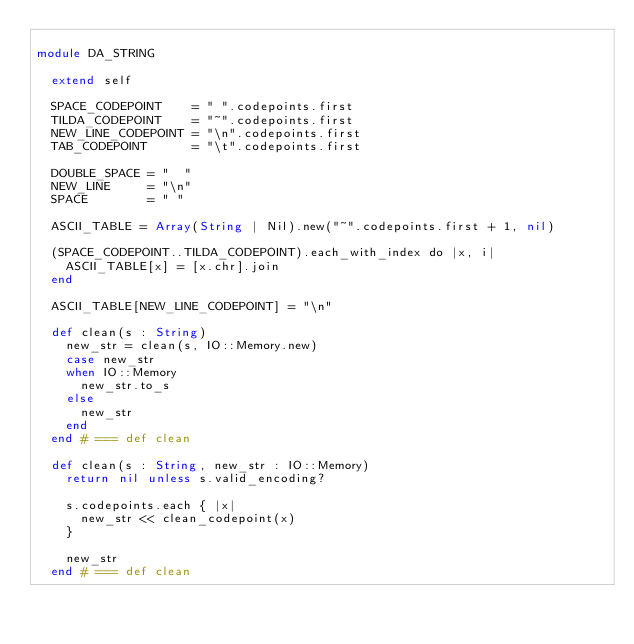<code> <loc_0><loc_0><loc_500><loc_500><_Crystal_>
module DA_STRING

  extend self

  SPACE_CODEPOINT    = " ".codepoints.first
  TILDA_CODEPOINT    = "~".codepoints.first
  NEW_LINE_CODEPOINT = "\n".codepoints.first
  TAB_CODEPOINT      = "\t".codepoints.first

  DOUBLE_SPACE = "  "
  NEW_LINE     = "\n"
  SPACE        = " "

  ASCII_TABLE = Array(String | Nil).new("~".codepoints.first + 1, nil)

  (SPACE_CODEPOINT..TILDA_CODEPOINT).each_with_index do |x, i|
    ASCII_TABLE[x] = [x.chr].join
  end

  ASCII_TABLE[NEW_LINE_CODEPOINT] = "\n"

  def clean(s : String)
    new_str = clean(s, IO::Memory.new)
    case new_str
    when IO::Memory
      new_str.to_s
    else
      new_str
    end
  end # === def clean

  def clean(s : String, new_str : IO::Memory)
    return nil unless s.valid_encoding?

    s.codepoints.each { |x|
      new_str << clean_codepoint(x)
    }

    new_str
  end # === def clean
</code> 